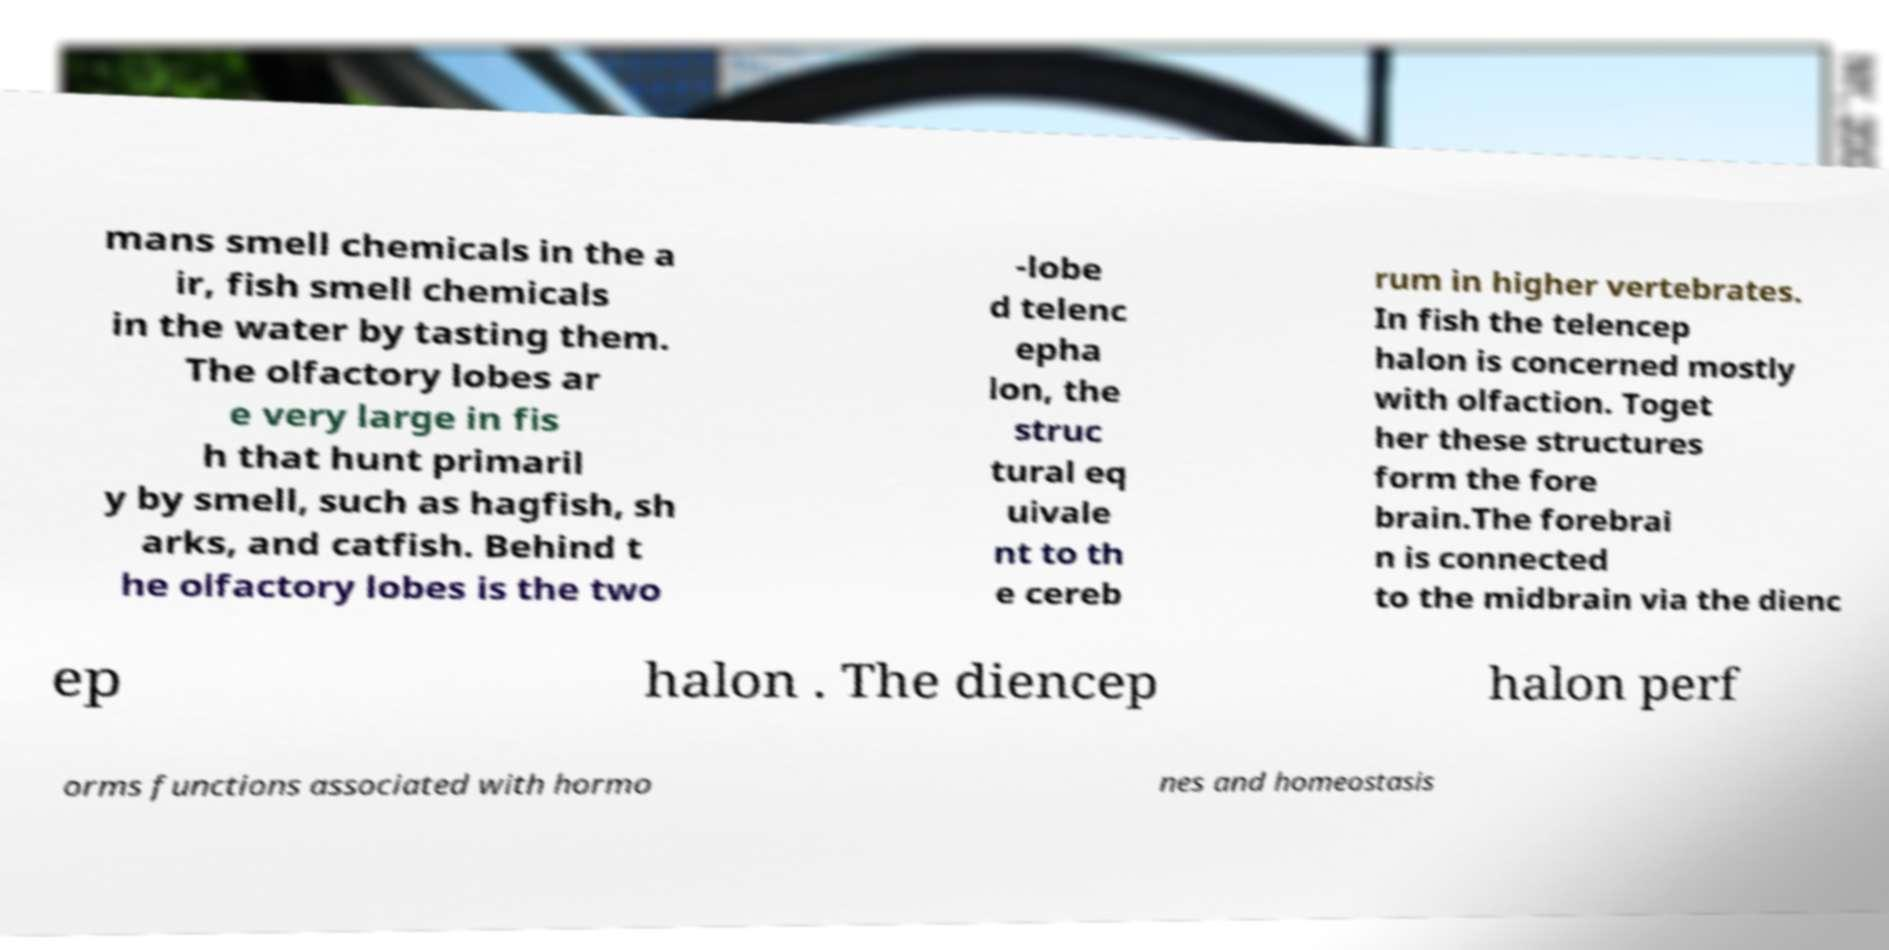Please read and relay the text visible in this image. What does it say? mans smell chemicals in the a ir, fish smell chemicals in the water by tasting them. The olfactory lobes ar e very large in fis h that hunt primaril y by smell, such as hagfish, sh arks, and catfish. Behind t he olfactory lobes is the two -lobe d telenc epha lon, the struc tural eq uivale nt to th e cereb rum in higher vertebrates. In fish the telencep halon is concerned mostly with olfaction. Toget her these structures form the fore brain.The forebrai n is connected to the midbrain via the dienc ep halon . The diencep halon perf orms functions associated with hormo nes and homeostasis 